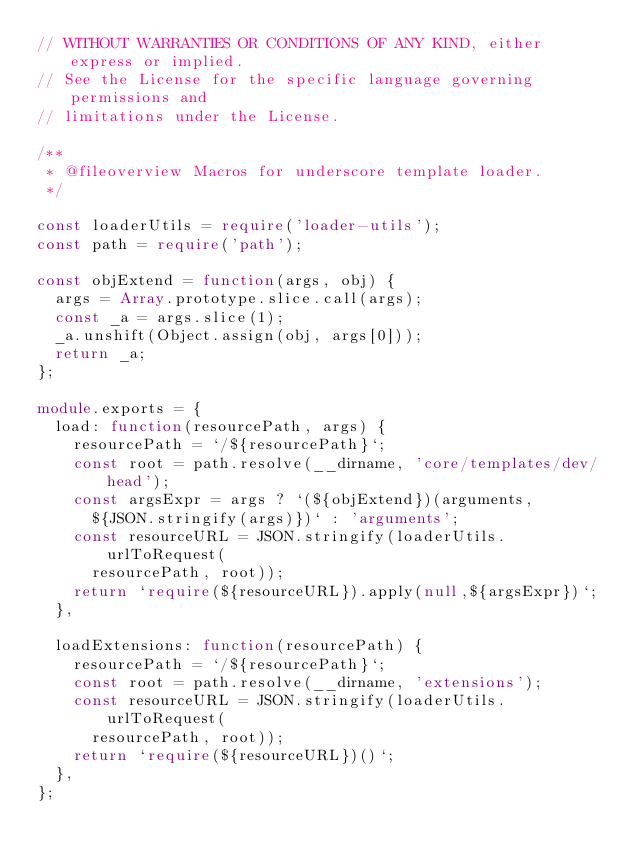<code> <loc_0><loc_0><loc_500><loc_500><_TypeScript_>// WITHOUT WARRANTIES OR CONDITIONS OF ANY KIND, either express or implied.
// See the License for the specific language governing permissions and
// limitations under the License.

/**
 * @fileoverview Macros for underscore template loader.
 */

const loaderUtils = require('loader-utils');
const path = require('path');

const objExtend = function(args, obj) {
  args = Array.prototype.slice.call(args);
  const _a = args.slice(1);
  _a.unshift(Object.assign(obj, args[0]));
  return _a;
};

module.exports = {
  load: function(resourcePath, args) {
    resourcePath = `/${resourcePath}`;
    const root = path.resolve(__dirname, 'core/templates/dev/head');
    const argsExpr = args ? `(${objExtend})(arguments,
      ${JSON.stringify(args)})` : 'arguments';
    const resourceURL = JSON.stringify(loaderUtils.urlToRequest(
      resourcePath, root));
    return `require(${resourceURL}).apply(null,${argsExpr})`;
  },

  loadExtensions: function(resourcePath) {
    resourcePath = `/${resourcePath}`;
    const root = path.resolve(__dirname, 'extensions');
    const resourceURL = JSON.stringify(loaderUtils.urlToRequest(
      resourcePath, root));
    return `require(${resourceURL})()`;
  },
};
</code> 